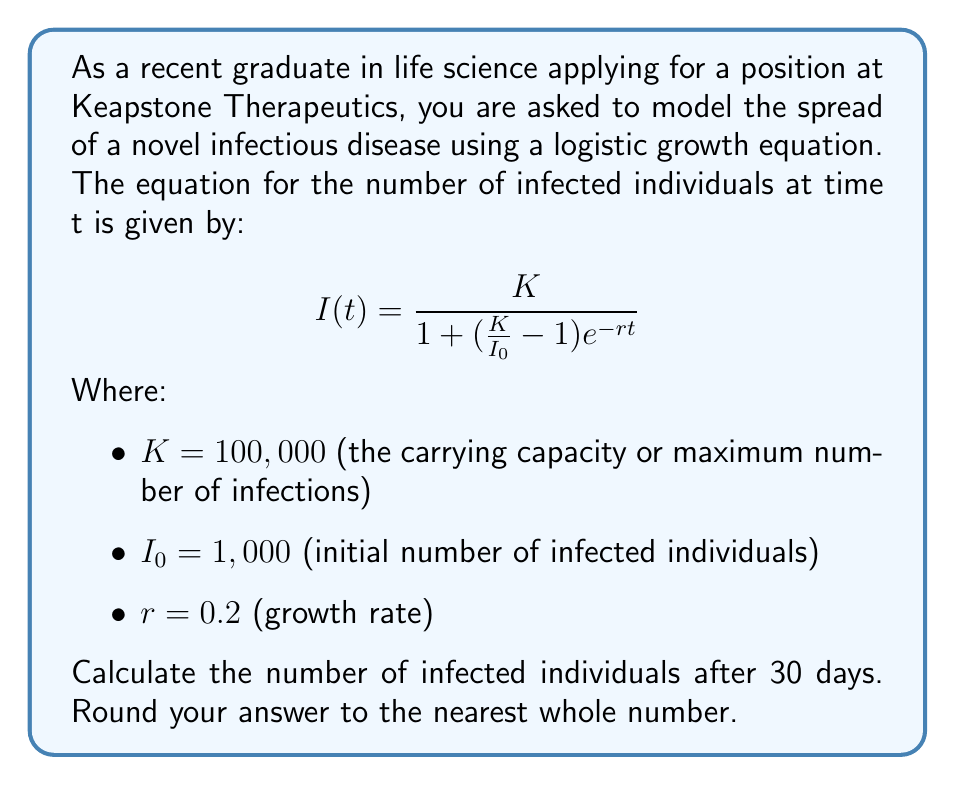Help me with this question. To solve this problem, we need to use the given logistic growth equation and substitute the known values:

$$I(t) = \frac{K}{1 + (\frac{K}{I_0} - 1)e^{-rt}}$$

Given:
$K = 100,000$
$I_0 = 1,000$
$r = 0.2$
$t = 30$ days

Let's substitute these values into the equation:

$$I(30) = \frac{100,000}{1 + (\frac{100,000}{1,000} - 1)e^{-0.2(30)}}$$

Simplify the fraction inside the parentheses:

$$I(30) = \frac{100,000}{1 + (100 - 1)e^{-6}}$$

$$I(30) = \frac{100,000}{1 + 99e^{-6}}$$

Now, let's calculate $e^{-6}$:

$e^{-6} \approx 0.00247875$

Substitute this value:

$$I(30) = \frac{100,000}{1 + 99(0.00247875)}$$

$$I(30) = \frac{100,000}{1 + 0.245396}$$

$$I(30) = \frac{100,000}{1.245396}$$

$$I(30) \approx 80,296.33$$

Rounding to the nearest whole number:

$$I(30) \approx 80,296$$

Therefore, after 30 days, the number of infected individuals would be approximately 80,296.
Answer: 80,296 